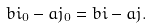<formula> <loc_0><loc_0><loc_500><loc_500>b i _ { 0 } - a j _ { 0 } = b i - a j .</formula> 